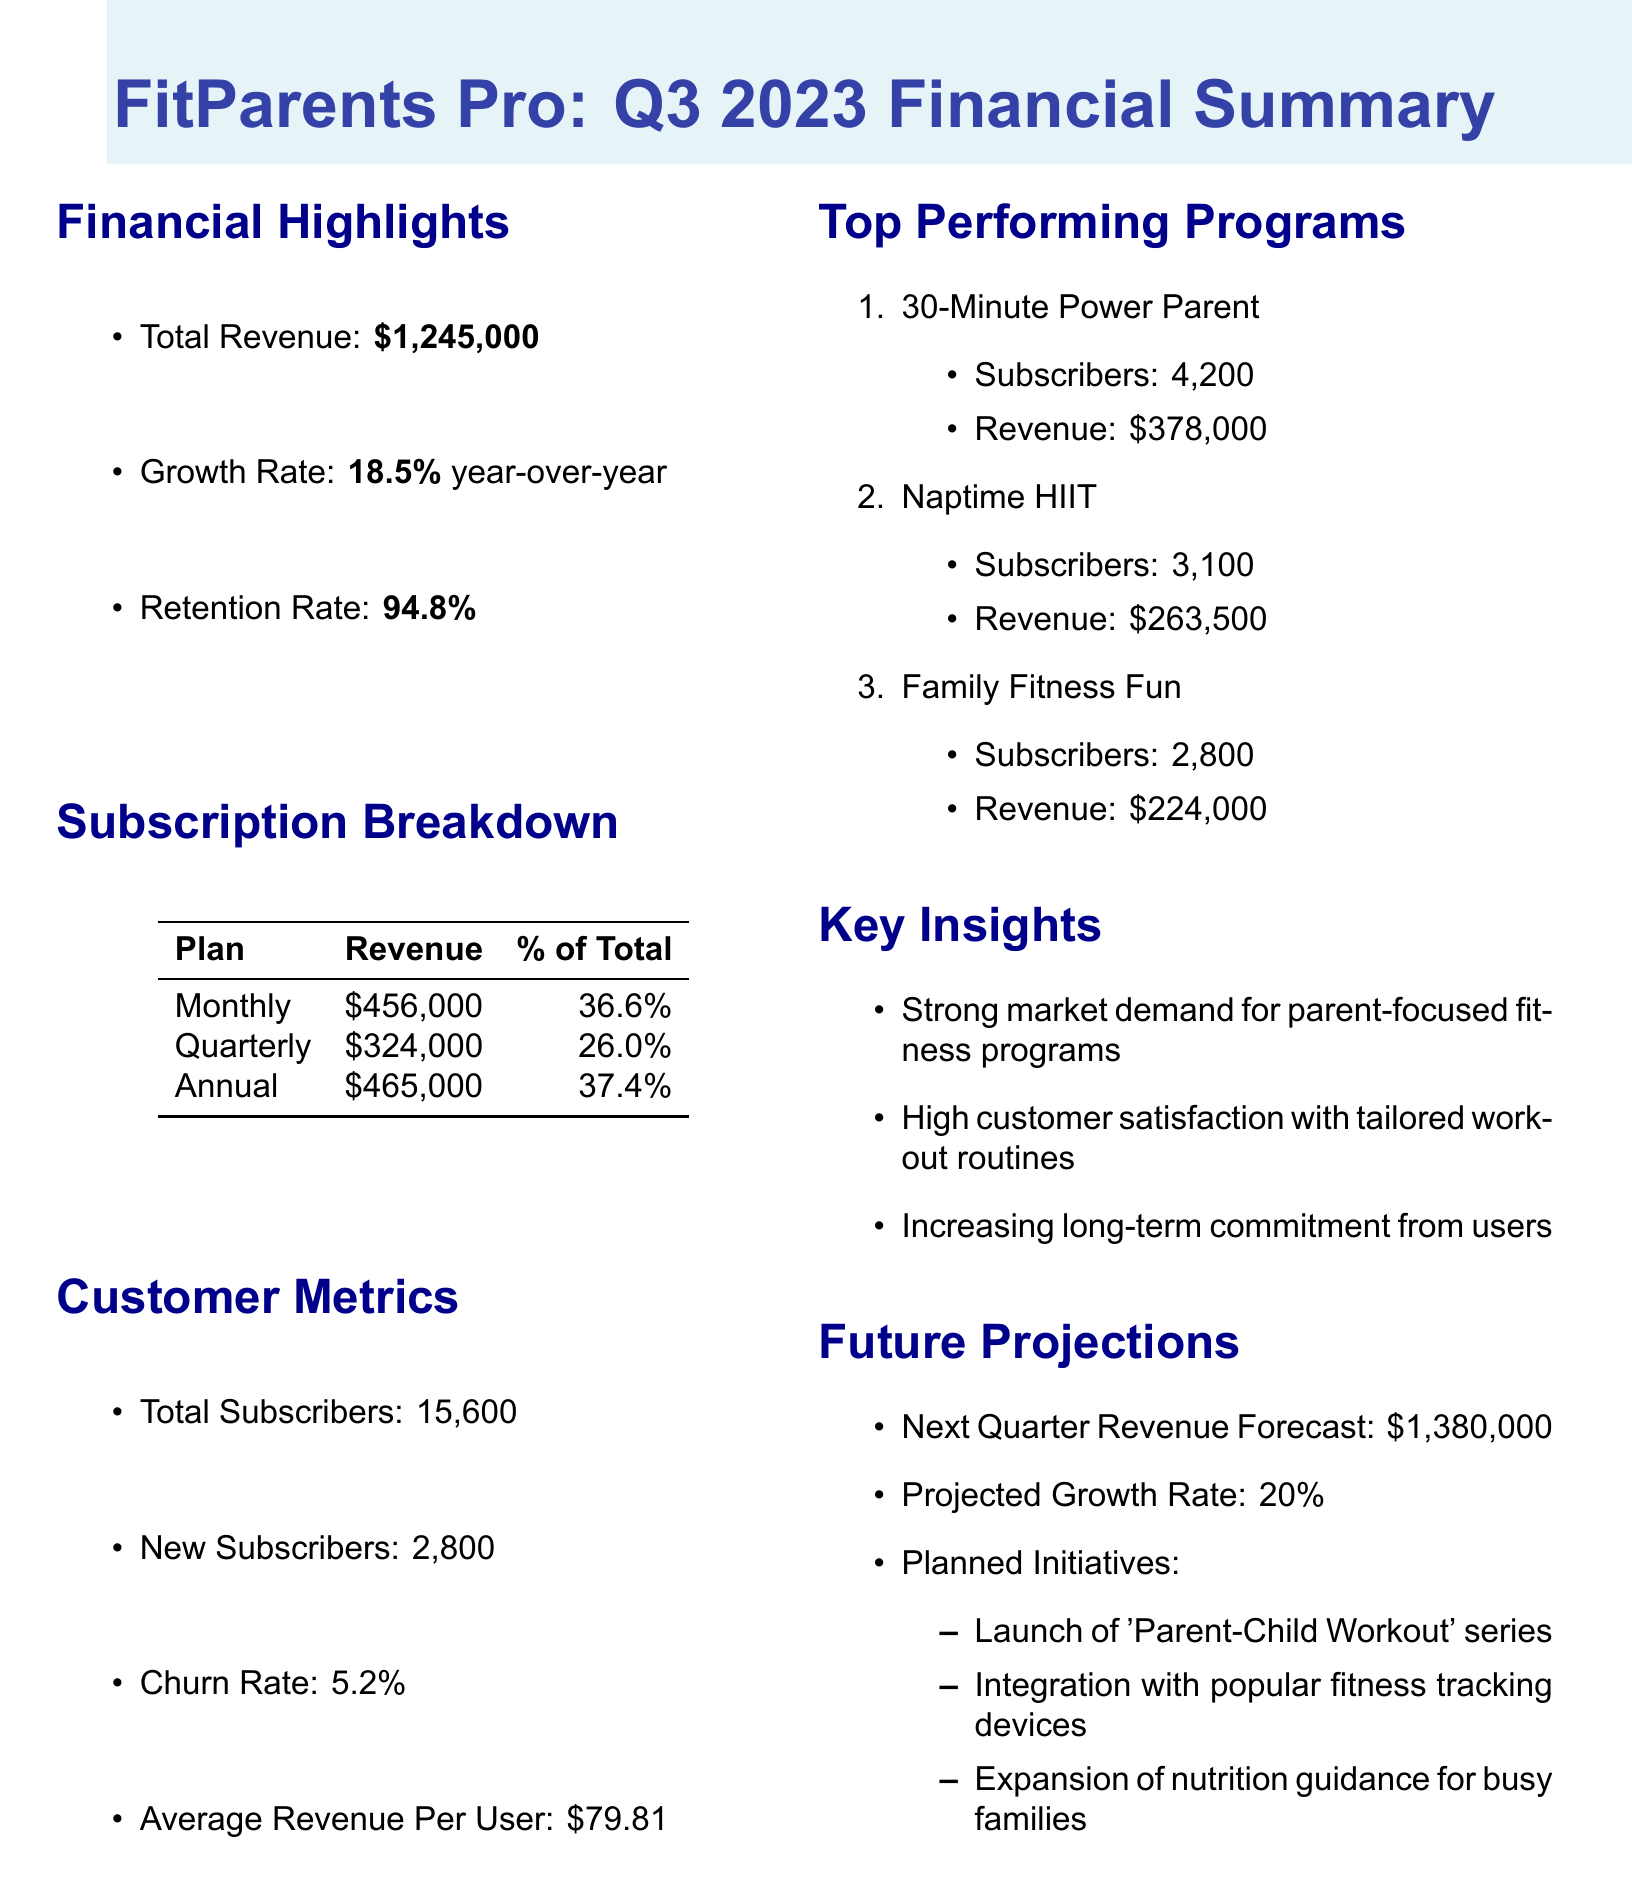what is the total revenue? The total revenue is mentioned in the financial highlights of the document as $1,245,000.
Answer: $1,245,000 what is the growth rate year-over-year? The growth rate is stated in the financial highlights section, which shows an increase of 18.5% compared to the previous year.
Answer: 18.5% what is the retention rate? The retention rate is provided in the financial highlights, indicating the percentage of customers that continue their subscriptions, which is 94.8%.
Answer: 94.8% how many total subscribers does FitParents Pro have? The total number of subscribers is outlined in the customer metrics, showing 15,600 subscribers.
Answer: 15,600 which subscription plan has the highest revenue? The subscription breakdown shows revenues from different plans, and the annual plan has the highest revenue of $465,000.
Answer: Annual what is the churn rate? The churn rate, which indicates the percentage of subscribers that discontinue their subscriptions, is found in the customer metrics and is 5.2%.
Answer: 5.2% what is the forecasted revenue for the next quarter? Future projections indicate the expected revenue for the upcoming quarter will be $1,380,000.
Answer: $1,380,000 how many new subscribers were added? The new subscribers figure is listed under customer metrics, stating that 2,800 new subscribers joined.
Answer: 2,800 what programs are included in the top performing programs? The document lists several top performing programs, including "30-Minute Power Parent," "Naptime HIIT," and "Family Fitness Fun."
Answer: 30-Minute Power Parent, Naptime HIIT, Family Fitness Fun what planned initiatives are mentioned for the future? The planned initiatives section outlines three future actions, which are launching a 'Parent-Child Workout' series, integrating with fitness tracking devices, and expanding nutrition guidance.
Answer: Launch of 'Parent-Child Workout' series, Integration with popular fitness tracking devices, Expansion of nutrition guidance for busy families 